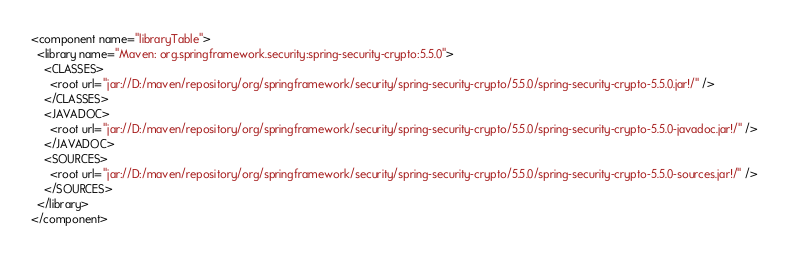<code> <loc_0><loc_0><loc_500><loc_500><_XML_><component name="libraryTable">
  <library name="Maven: org.springframework.security:spring-security-crypto:5.5.0">
    <CLASSES>
      <root url="jar://D:/maven/repository/org/springframework/security/spring-security-crypto/5.5.0/spring-security-crypto-5.5.0.jar!/" />
    </CLASSES>
    <JAVADOC>
      <root url="jar://D:/maven/repository/org/springframework/security/spring-security-crypto/5.5.0/spring-security-crypto-5.5.0-javadoc.jar!/" />
    </JAVADOC>
    <SOURCES>
      <root url="jar://D:/maven/repository/org/springframework/security/spring-security-crypto/5.5.0/spring-security-crypto-5.5.0-sources.jar!/" />
    </SOURCES>
  </library>
</component></code> 